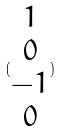Convert formula to latex. <formula><loc_0><loc_0><loc_500><loc_500>( \begin{matrix} 1 \\ 0 \\ - 1 \\ 0 \end{matrix} )</formula> 